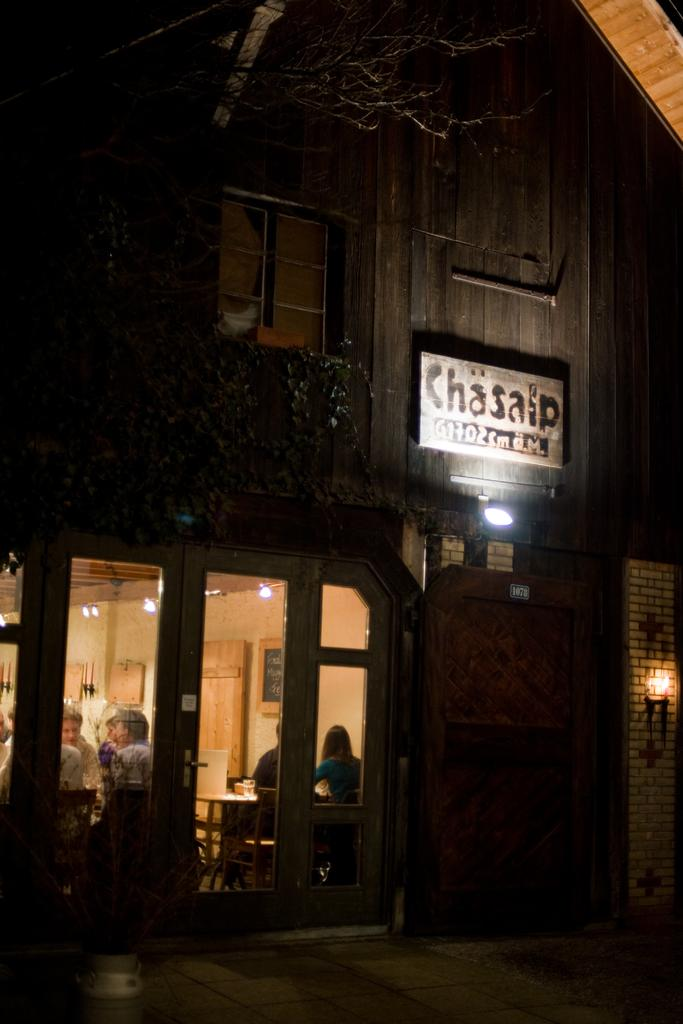<image>
Write a terse but informative summary of the picture. a sign that has the word Chasaip on it 